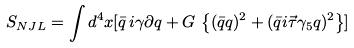<formula> <loc_0><loc_0><loc_500><loc_500>S _ { N J L } = \int d ^ { 4 } x [ \bar { q } \, i { \gamma \partial } q + G \, \left \{ ( \bar { q } q ) ^ { 2 } + ( \bar { q } i \vec { \tau } \gamma _ { 5 } q ) ^ { 2 } \right \} ] \,</formula> 